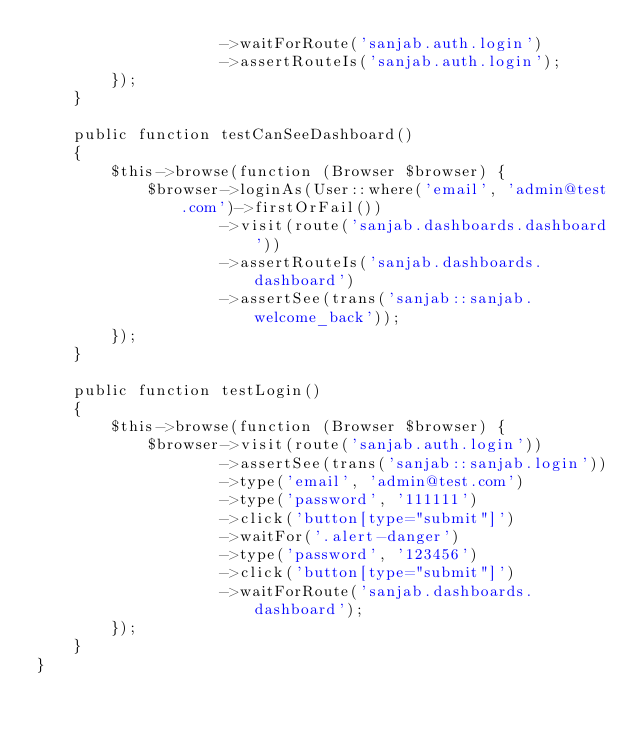Convert code to text. <code><loc_0><loc_0><loc_500><loc_500><_PHP_>                    ->waitForRoute('sanjab.auth.login')
                    ->assertRouteIs('sanjab.auth.login');
        });
    }

    public function testCanSeeDashboard()
    {
        $this->browse(function (Browser $browser) {
            $browser->loginAs(User::where('email', 'admin@test.com')->firstOrFail())
                    ->visit(route('sanjab.dashboards.dashboard'))
                    ->assertRouteIs('sanjab.dashboards.dashboard')
                    ->assertSee(trans('sanjab::sanjab.welcome_back'));
        });
    }

    public function testLogin()
    {
        $this->browse(function (Browser $browser) {
            $browser->visit(route('sanjab.auth.login'))
                    ->assertSee(trans('sanjab::sanjab.login'))
                    ->type('email', 'admin@test.com')
                    ->type('password', '111111')
                    ->click('button[type="submit"]')
                    ->waitFor('.alert-danger')
                    ->type('password', '123456')
                    ->click('button[type="submit"]')
                    ->waitForRoute('sanjab.dashboards.dashboard');
        });
    }
}
</code> 